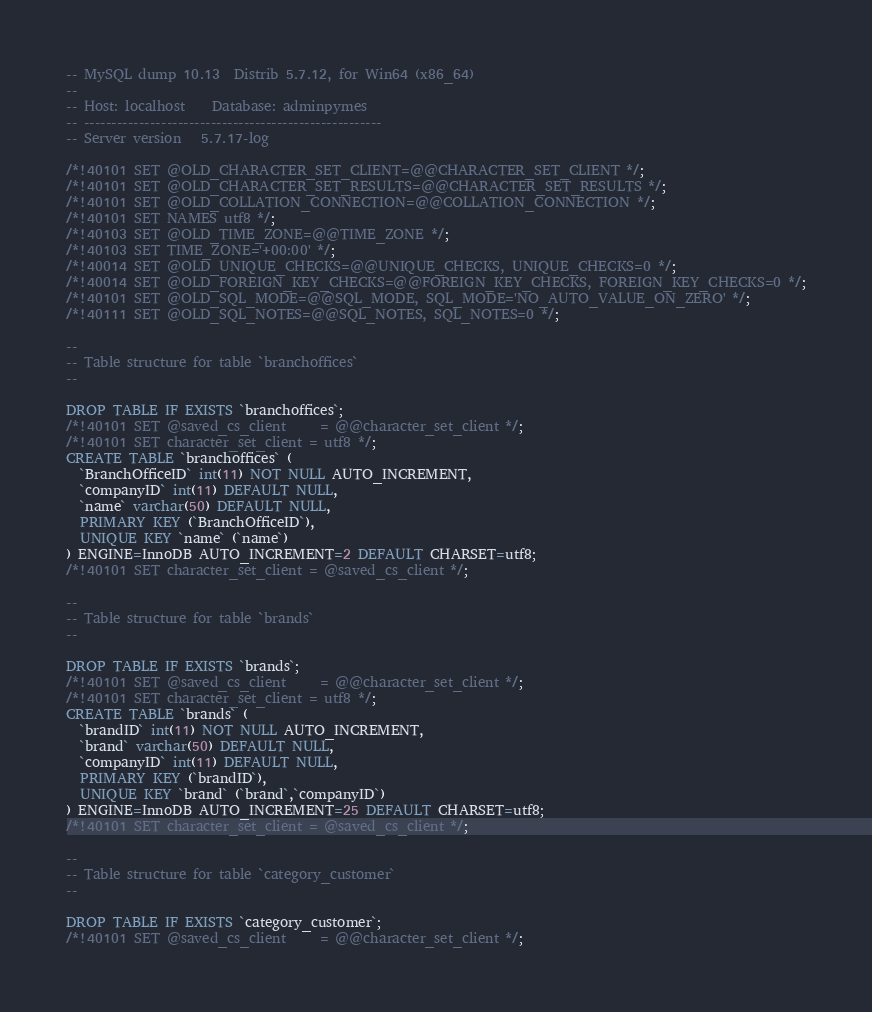<code> <loc_0><loc_0><loc_500><loc_500><_SQL_>-- MySQL dump 10.13  Distrib 5.7.12, for Win64 (x86_64)
--
-- Host: localhost    Database: adminpymes
-- ------------------------------------------------------
-- Server version	5.7.17-log

/*!40101 SET @OLD_CHARACTER_SET_CLIENT=@@CHARACTER_SET_CLIENT */;
/*!40101 SET @OLD_CHARACTER_SET_RESULTS=@@CHARACTER_SET_RESULTS */;
/*!40101 SET @OLD_COLLATION_CONNECTION=@@COLLATION_CONNECTION */;
/*!40101 SET NAMES utf8 */;
/*!40103 SET @OLD_TIME_ZONE=@@TIME_ZONE */;
/*!40103 SET TIME_ZONE='+00:00' */;
/*!40014 SET @OLD_UNIQUE_CHECKS=@@UNIQUE_CHECKS, UNIQUE_CHECKS=0 */;
/*!40014 SET @OLD_FOREIGN_KEY_CHECKS=@@FOREIGN_KEY_CHECKS, FOREIGN_KEY_CHECKS=0 */;
/*!40101 SET @OLD_SQL_MODE=@@SQL_MODE, SQL_MODE='NO_AUTO_VALUE_ON_ZERO' */;
/*!40111 SET @OLD_SQL_NOTES=@@SQL_NOTES, SQL_NOTES=0 */;

--
-- Table structure for table `branchoffices`
--

DROP TABLE IF EXISTS `branchoffices`;
/*!40101 SET @saved_cs_client     = @@character_set_client */;
/*!40101 SET character_set_client = utf8 */;
CREATE TABLE `branchoffices` (
  `BranchOfficeID` int(11) NOT NULL AUTO_INCREMENT,
  `companyID` int(11) DEFAULT NULL,
  `name` varchar(50) DEFAULT NULL,
  PRIMARY KEY (`BranchOfficeID`),
  UNIQUE KEY `name` (`name`)
) ENGINE=InnoDB AUTO_INCREMENT=2 DEFAULT CHARSET=utf8;
/*!40101 SET character_set_client = @saved_cs_client */;

--
-- Table structure for table `brands`
--

DROP TABLE IF EXISTS `brands`;
/*!40101 SET @saved_cs_client     = @@character_set_client */;
/*!40101 SET character_set_client = utf8 */;
CREATE TABLE `brands` (
  `brandID` int(11) NOT NULL AUTO_INCREMENT,
  `brand` varchar(50) DEFAULT NULL,
  `companyID` int(11) DEFAULT NULL,
  PRIMARY KEY (`brandID`),
  UNIQUE KEY `brand` (`brand`,`companyID`)
) ENGINE=InnoDB AUTO_INCREMENT=25 DEFAULT CHARSET=utf8;
/*!40101 SET character_set_client = @saved_cs_client */;

--
-- Table structure for table `category_customer`
--

DROP TABLE IF EXISTS `category_customer`;
/*!40101 SET @saved_cs_client     = @@character_set_client */;</code> 